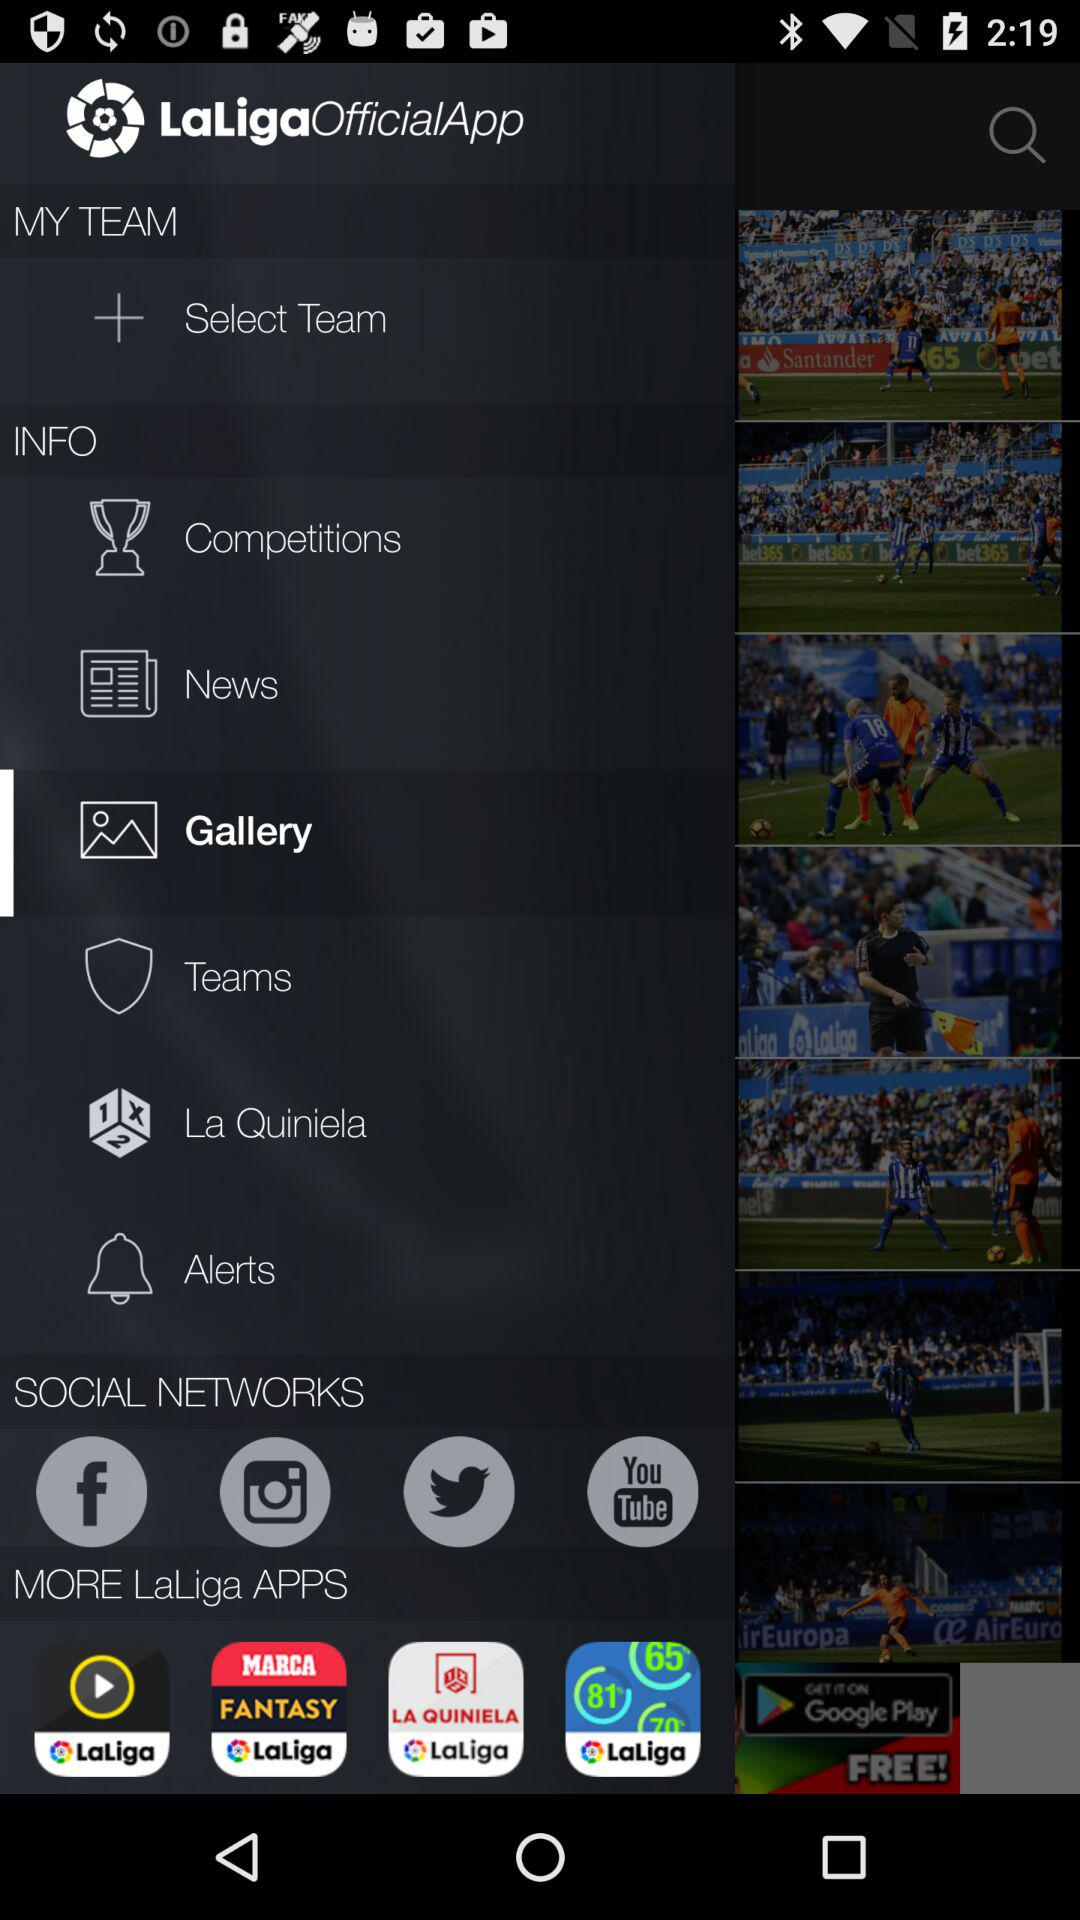Which tab has been selected? The selected tab is Gallery. 